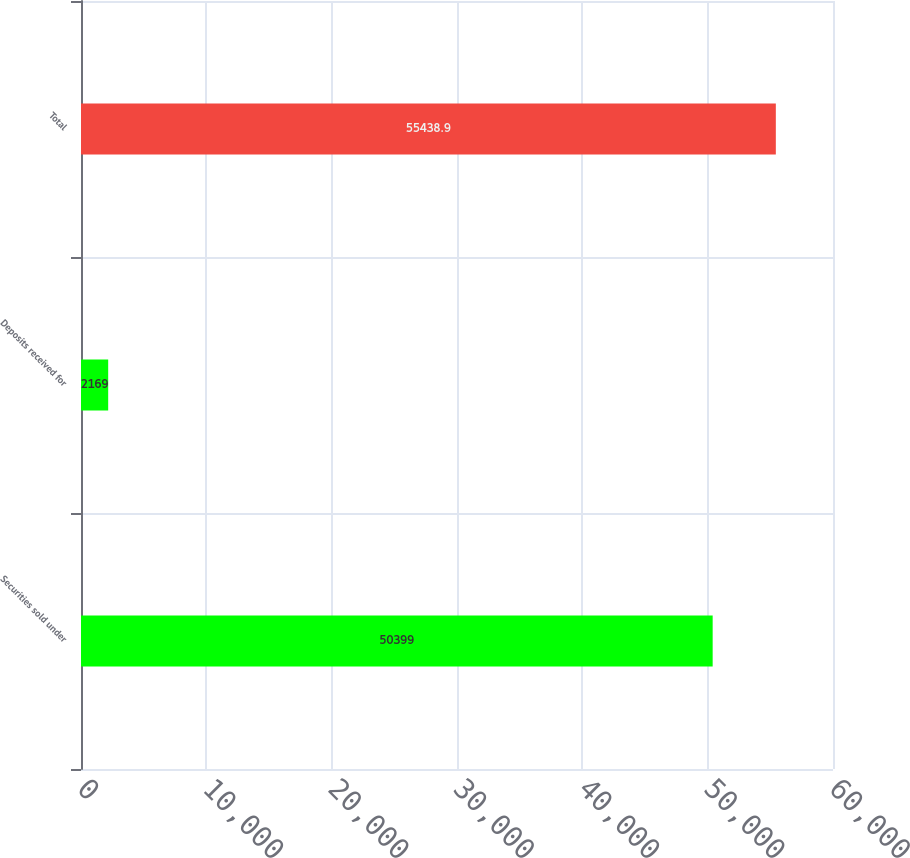Convert chart to OTSL. <chart><loc_0><loc_0><loc_500><loc_500><bar_chart><fcel>Securities sold under<fcel>Deposits received for<fcel>Total<nl><fcel>50399<fcel>2169<fcel>55438.9<nl></chart> 